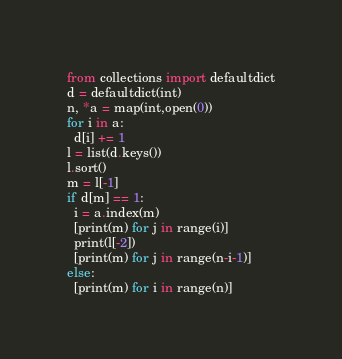<code> <loc_0><loc_0><loc_500><loc_500><_Python_>from collections import defaultdict
d = defaultdict(int)
n, *a = map(int,open(0))
for i in a:
  d[i] += 1
l = list(d.keys())
l.sort()
m = l[-1]
if d[m] == 1:
  i = a.index(m)
  [print(m) for j in range(i)]
  print(l[-2])
  [print(m) for j in range(n-i-1)]
else:
  [print(m) for i in range(n)]</code> 